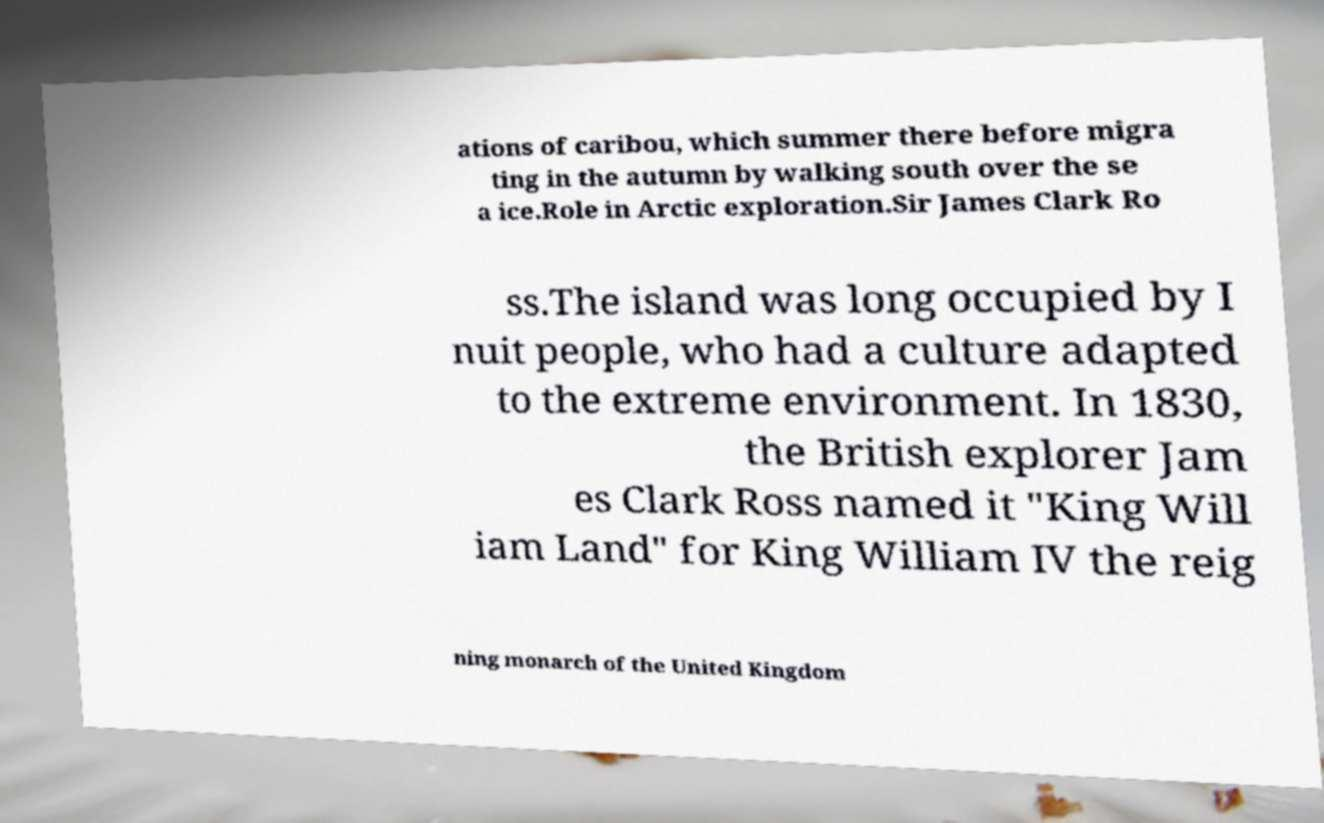Please read and relay the text visible in this image. What does it say? ations of caribou, which summer there before migra ting in the autumn by walking south over the se a ice.Role in Arctic exploration.Sir James Clark Ro ss.The island was long occupied by I nuit people, who had a culture adapted to the extreme environment. In 1830, the British explorer Jam es Clark Ross named it "King Will iam Land" for King William IV the reig ning monarch of the United Kingdom 